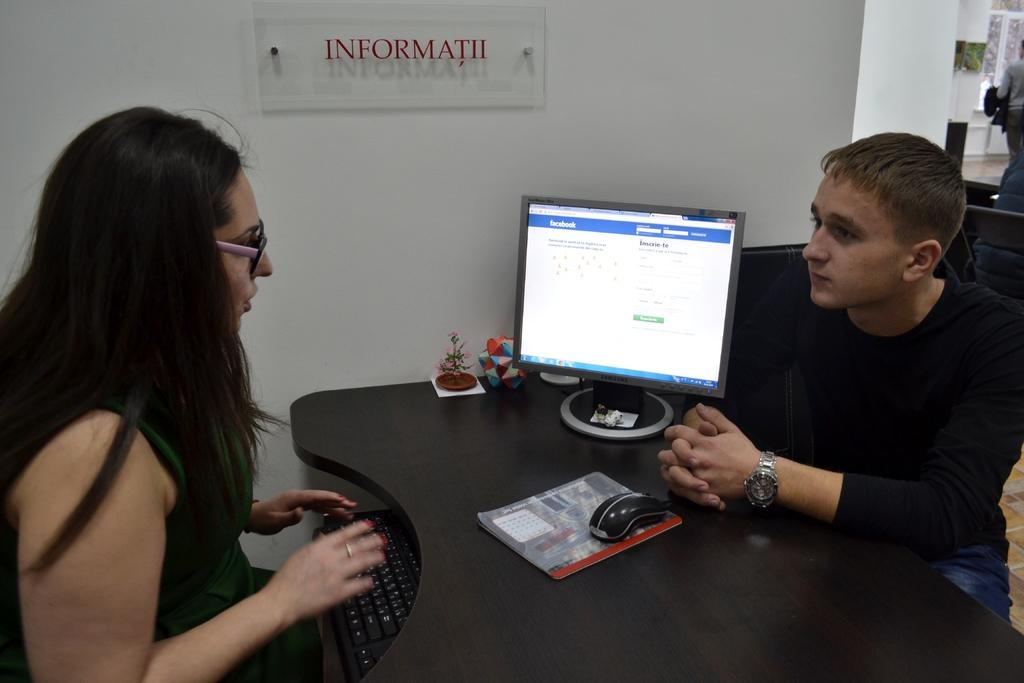<image>
Summarize the visual content of the image. Two people sit under a sign that says Informatii. 